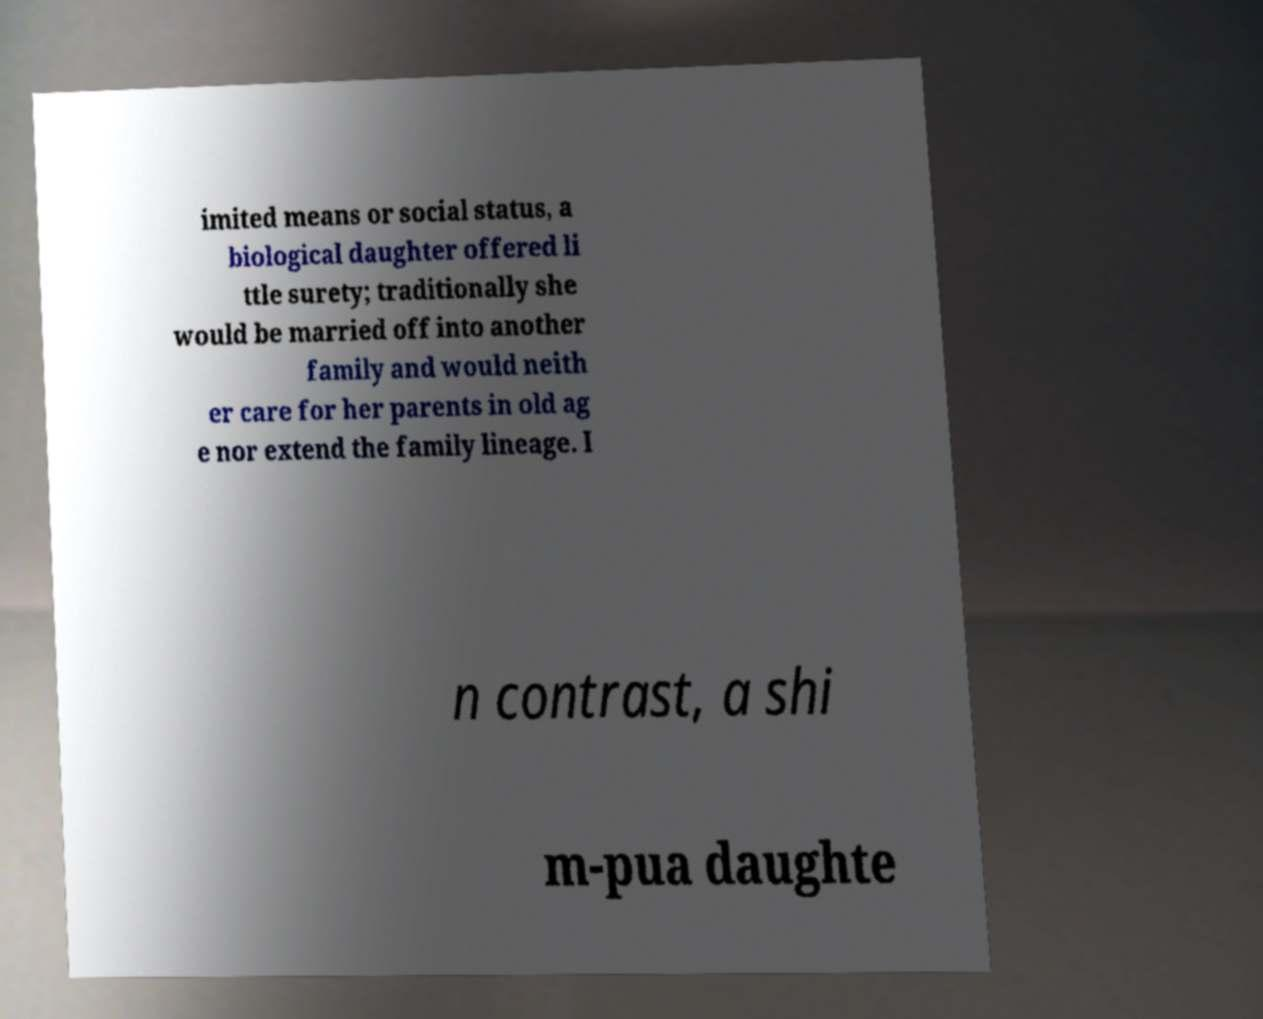What messages or text are displayed in this image? I need them in a readable, typed format. imited means or social status, a biological daughter offered li ttle surety; traditionally she would be married off into another family and would neith er care for her parents in old ag e nor extend the family lineage. I n contrast, a shi m-pua daughte 